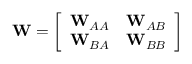Convert formula to latex. <formula><loc_0><loc_0><loc_500><loc_500>W = \left [ \begin{array} { l l } { W _ { A A } } & { W _ { A B } } \\ { W _ { B A } } & { W _ { B B } } \end{array} \right ]</formula> 